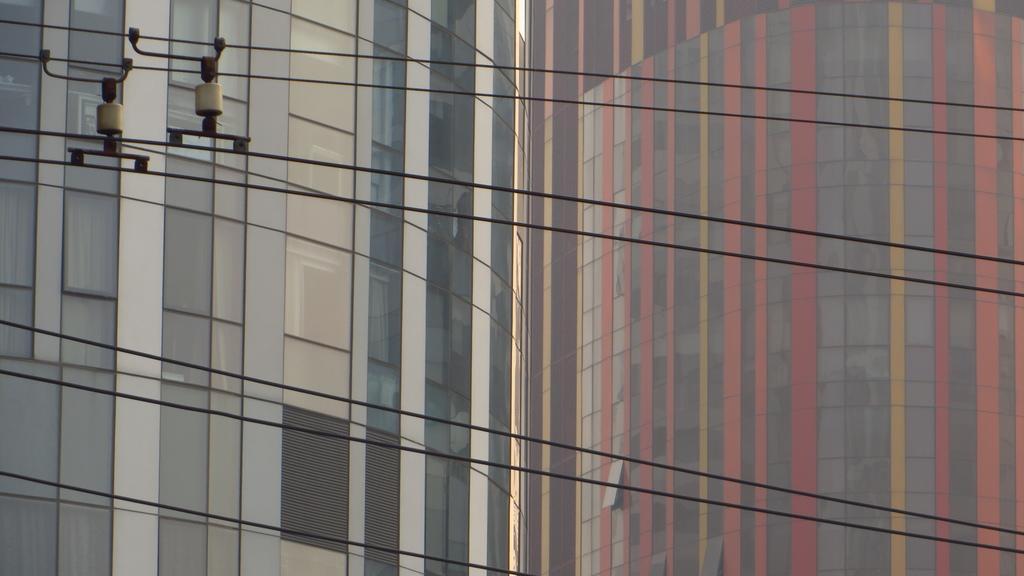Describe this image in one or two sentences. In this image we can see some buildings. In the foreground we can see some rods on the cables. 